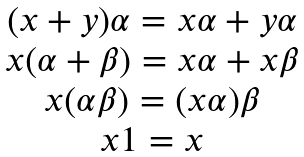Convert formula to latex. <formula><loc_0><loc_0><loc_500><loc_500>\begin{array} { c } ( x + y ) \alpha = x \alpha + y \alpha \\ x ( \alpha + \beta ) = x \alpha + x \beta \\ x ( \alpha \beta ) = ( x \alpha ) \beta \\ x 1 = x \end{array}</formula> 